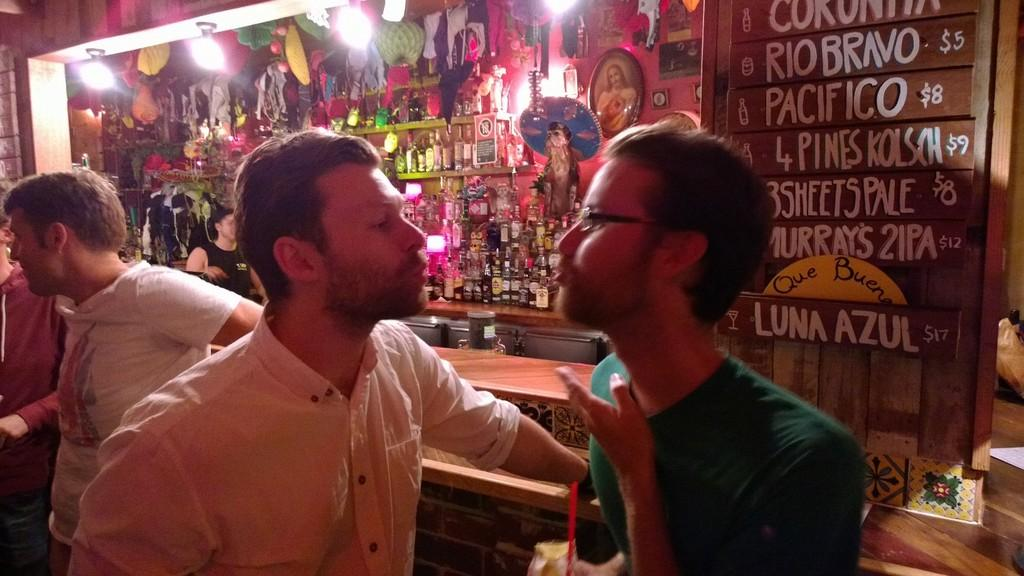What is happening in the image involving the people? Two people are speaking to each other in the image. What else can be seen in the image besides the people? There are bottles visible in the image. What type of snail can be seen crawling on the person's shoulder in the image? There is no snail present in the image; only people and bottles are visible. 